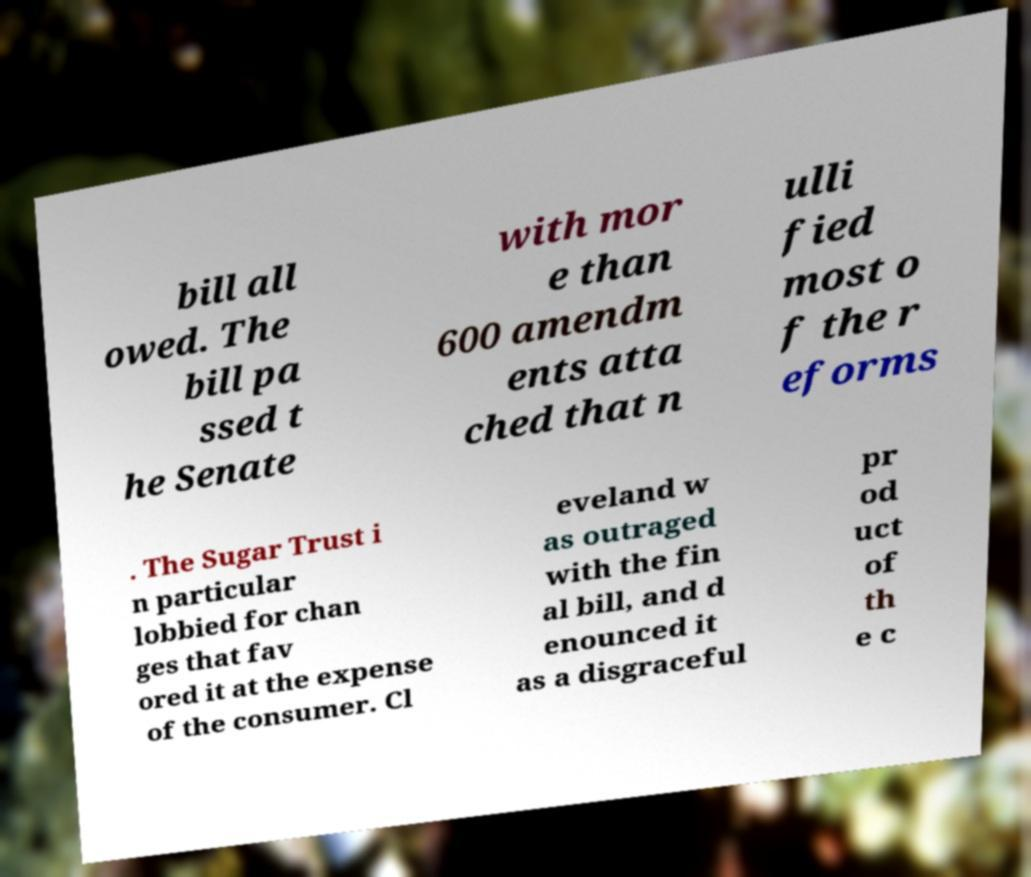There's text embedded in this image that I need extracted. Can you transcribe it verbatim? bill all owed. The bill pa ssed t he Senate with mor e than 600 amendm ents atta ched that n ulli fied most o f the r eforms . The Sugar Trust i n particular lobbied for chan ges that fav ored it at the expense of the consumer. Cl eveland w as outraged with the fin al bill, and d enounced it as a disgraceful pr od uct of th e c 